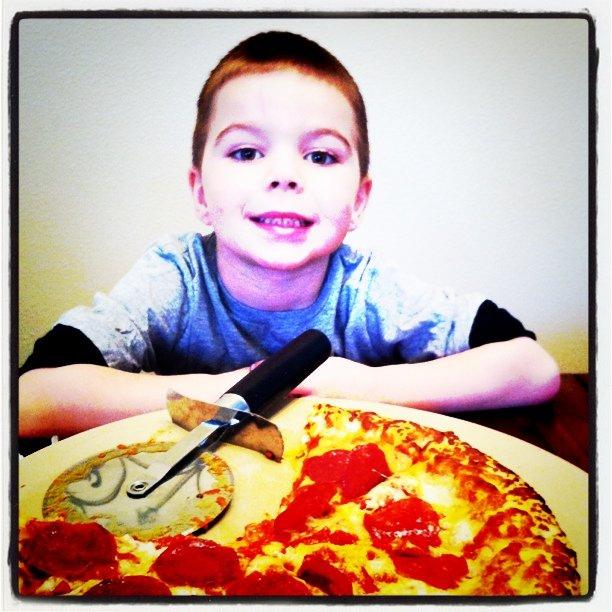Is the boy wearing 2 shirts?
Quick response, please. Yes. What utensils are on the plate?
Answer briefly. Pizza cutter. What kind of pizza is in the picture?
Concise answer only. Pepperoni. What is used to cut the pizza?
Give a very brief answer. Pizza cutter. 